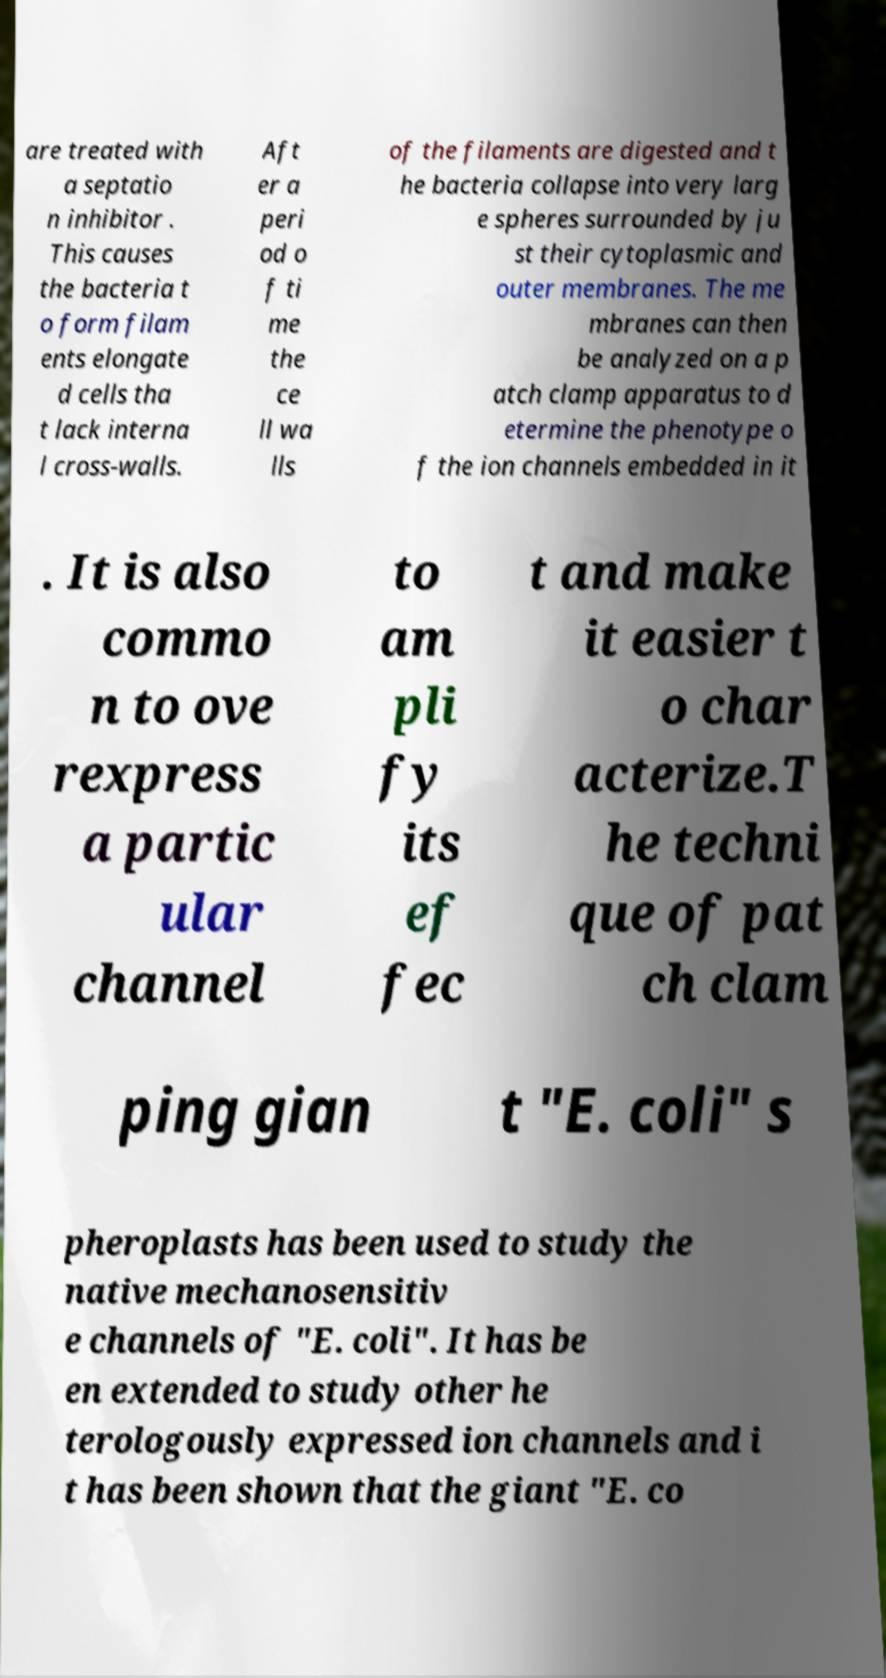I need the written content from this picture converted into text. Can you do that? are treated with a septatio n inhibitor . This causes the bacteria t o form filam ents elongate d cells tha t lack interna l cross-walls. Aft er a peri od o f ti me the ce ll wa lls of the filaments are digested and t he bacteria collapse into very larg e spheres surrounded by ju st their cytoplasmic and outer membranes. The me mbranes can then be analyzed on a p atch clamp apparatus to d etermine the phenotype o f the ion channels embedded in it . It is also commo n to ove rexpress a partic ular channel to am pli fy its ef fec t and make it easier t o char acterize.T he techni que of pat ch clam ping gian t "E. coli" s pheroplasts has been used to study the native mechanosensitiv e channels of "E. coli". It has be en extended to study other he terologously expressed ion channels and i t has been shown that the giant "E. co 